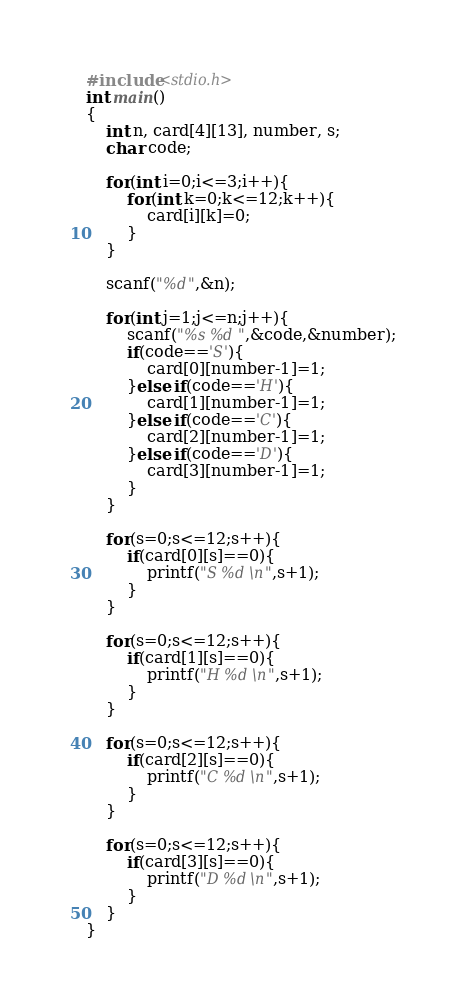<code> <loc_0><loc_0><loc_500><loc_500><_C_>#include<stdio.h>
int main()
{
	int n, card[4][13], number, s;
	char code;

	for(int i=0;i<=3;i++){
		for(int k=0;k<=12;k++){
			card[i][k]=0;
		}
	}

	scanf("%d",&n);

	for(int j=1;j<=n;j++){
		scanf("%s %d",&code,&number);
		if(code=='S'){
			card[0][number-1]=1;
		}else if(code=='H'){
			card[1][number-1]=1;
		}else if(code=='C'){
			card[2][number-1]=1;
		}else if(code=='D'){
			card[3][number-1]=1;
		}
	}

	for(s=0;s<=12;s++){
		if(card[0][s]==0){
			printf("S %d\n",s+1);
		}
	}

	for(s=0;s<=12;s++){
		if(card[1][s]==0){
			printf("H %d\n",s+1);
		}
	}

	for(s=0;s<=12;s++){
		if(card[2][s]==0){
			printf("C %d\n",s+1);
		}
	}

	for(s=0;s<=12;s++){
		if(card[3][s]==0){
			printf("D %d\n",s+1);
		}
	}
}

</code> 